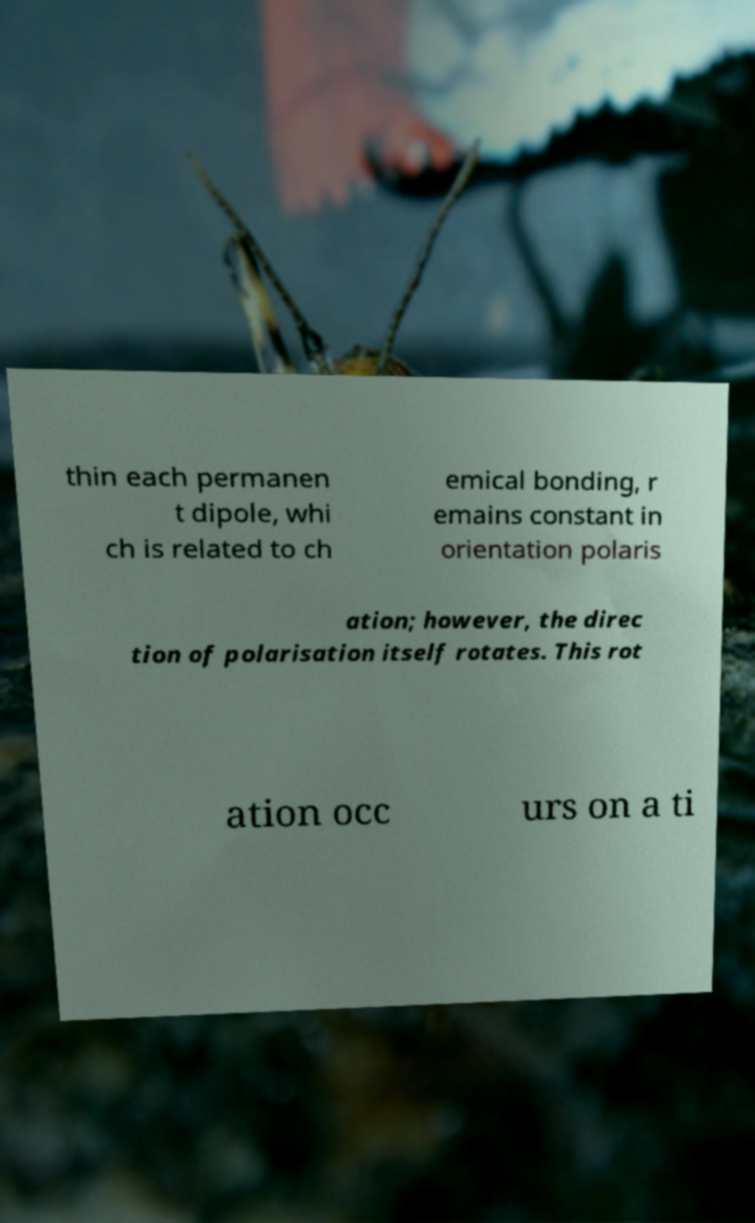For documentation purposes, I need the text within this image transcribed. Could you provide that? thin each permanen t dipole, whi ch is related to ch emical bonding, r emains constant in orientation polaris ation; however, the direc tion of polarisation itself rotates. This rot ation occ urs on a ti 